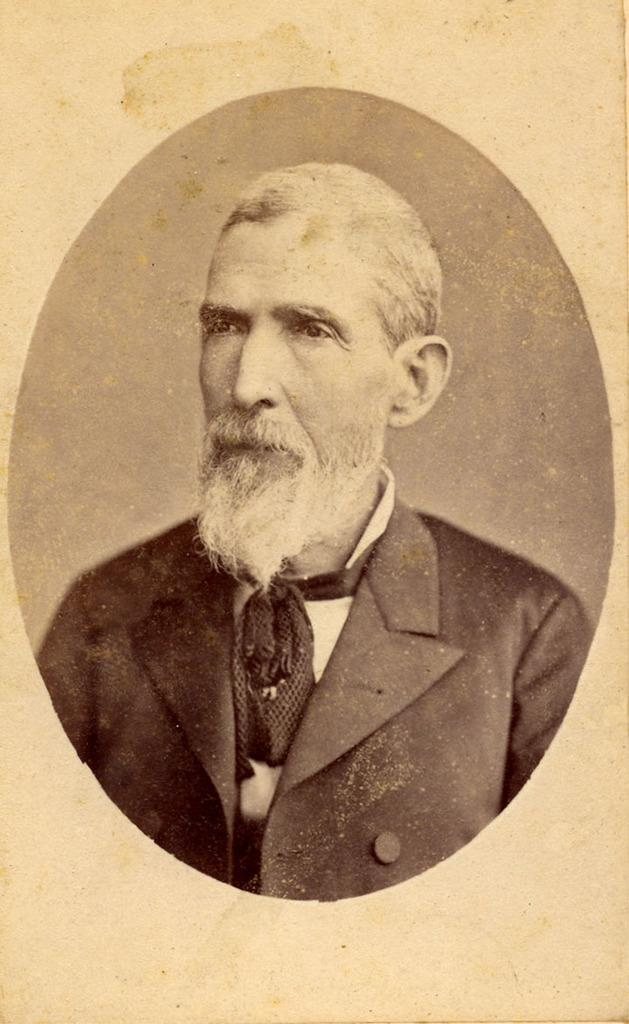What is the main subject of the image? The main subject of the image is a person. What is the person wearing in the image? The person is wearing a black suit in the image. How many trees are visible in the image? There are no trees visible in the image; it only features a picture of a person wearing a black suit. Is there a girl in the image? The image does not show a girl; it only features a person wearing a black suit. 